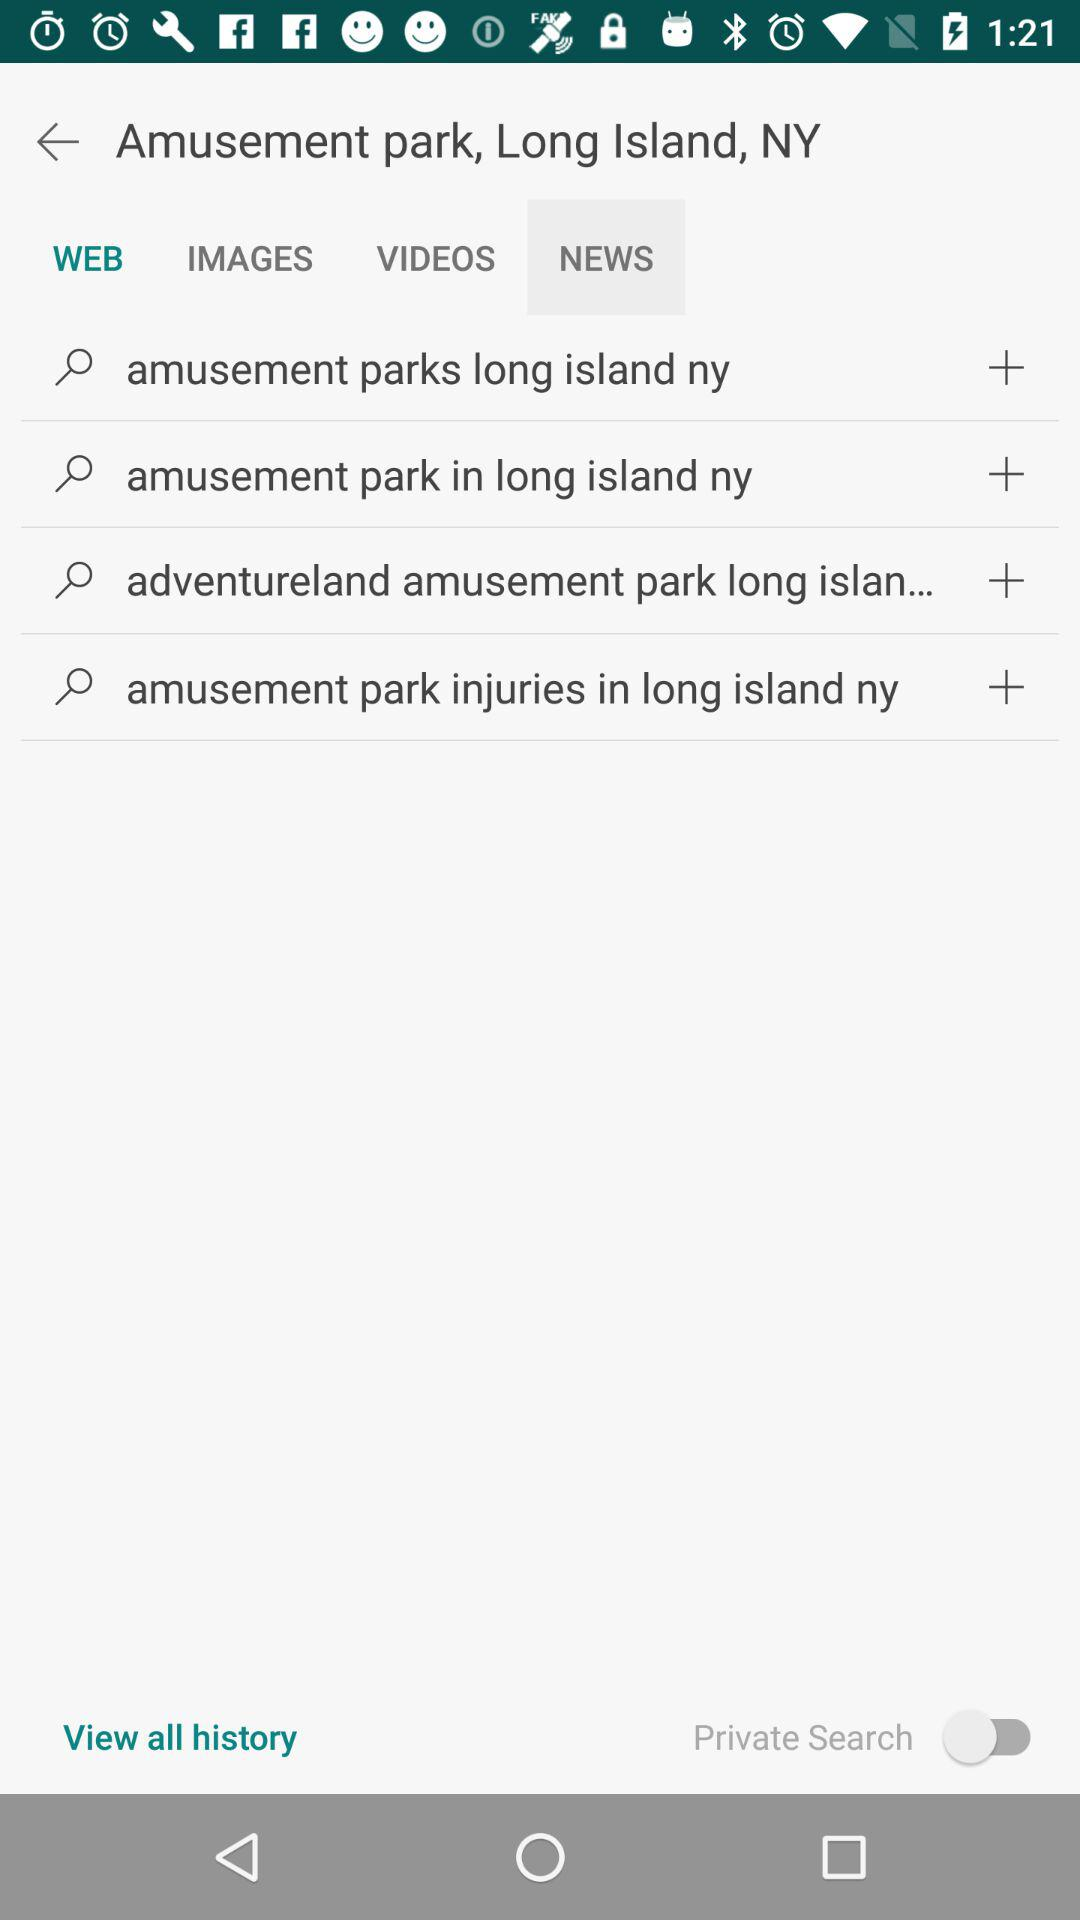Which tab is selected? The tab "WEB" is selected. 